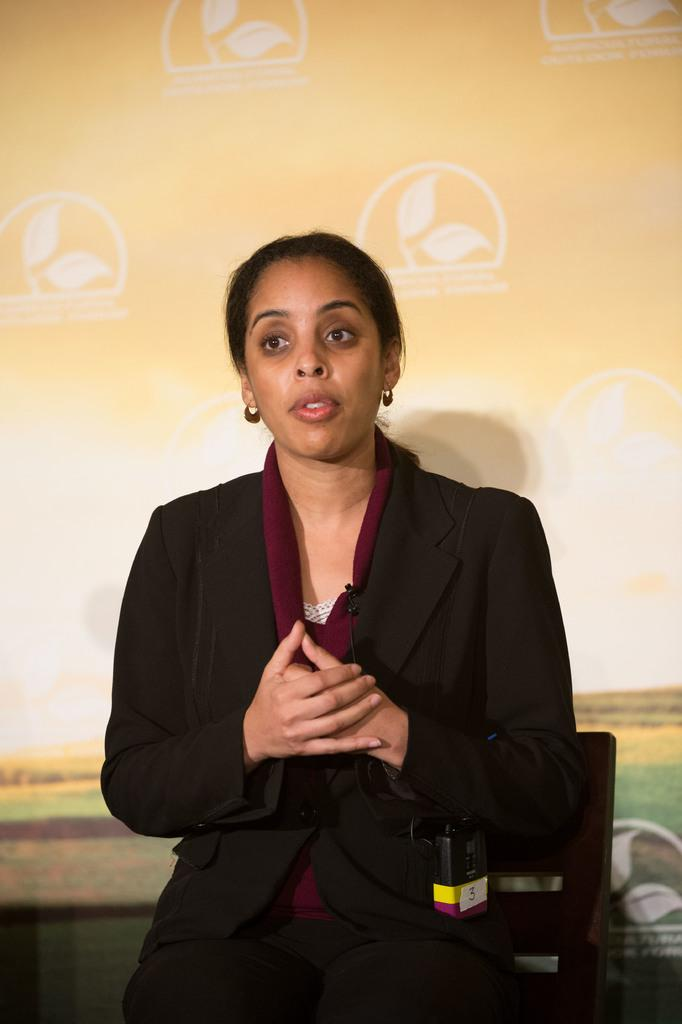Who is the main subject in the foreground of the image? There is a woman in the foreground of the image. What is the woman doing in the image? The woman is sitting on a chair and talking. What can be seen in the background of the image? A: There is a board in the background of the image. What is written on the board? There is text on the board. Can you tell me how many hens are sitting on the woman's lap in the image? There are no hens present in the image; the woman is sitting on a chair and talking. What type of cream is being used by the woman to write on the board? There is no cream visible in the image, and the woman is not writing on the board. 